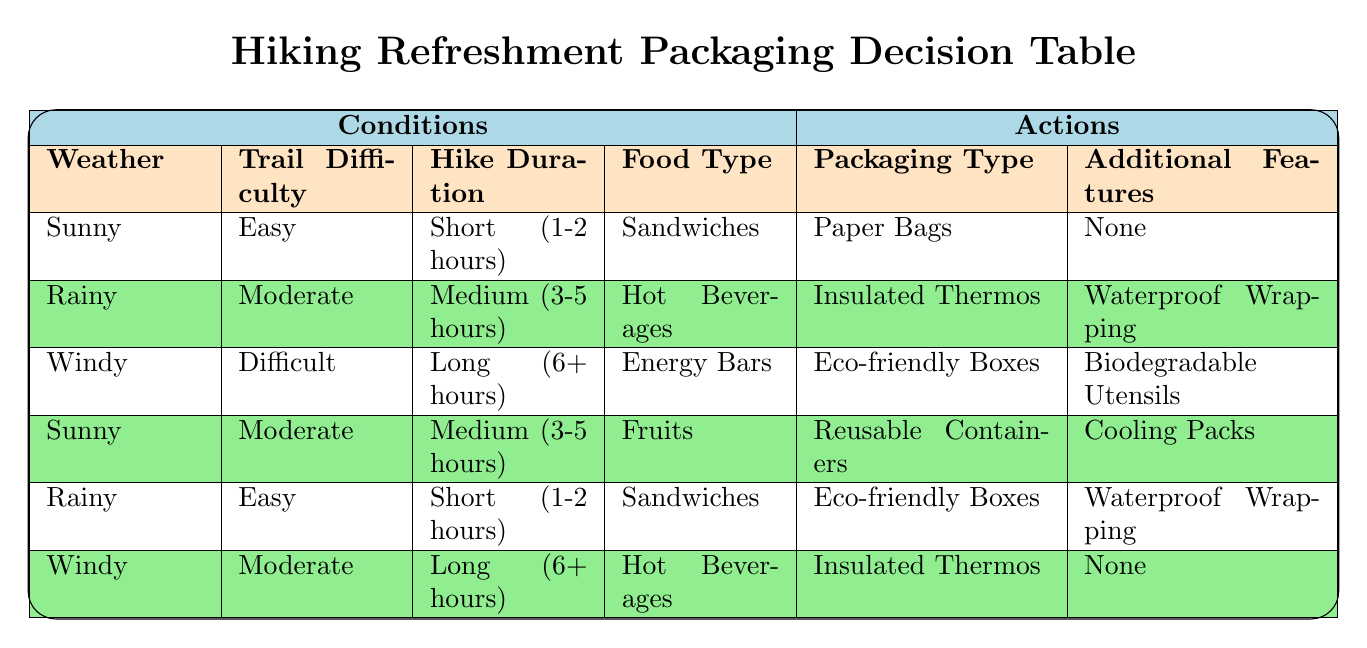What type of packaging should I use for sandwiches on a sunny day with an easy trail? According to the table, if the conditions are sunny, the trail is easy, the hike duration is short (1-2 hours), and the food type is sandwiches, the recommended packaging type is paper bags with no additional features. This is found in the first row of the table.
Answer: Paper bags If it's windy and the trail is difficult, what type of packaging should I avoid? The table indicates that when the conditions are windy and the trail is difficult, the suggested packaging type is eco-friendly boxes with biodegradable utensils. Thus, if looking for packaging to avoid, one could eliminate other options like insulated thermos or paper bags.
Answer: Avoid insulated thermos and paper bags Is waterproof wrapping required for hot beverages on a rainy day with moderate trail difficulty? The table specifies that for rainy weather, moderate trail difficulty, and hot beverages, the required packaging is insulated thermos with waterproof wrapping. Therefore, waterproof wrapping is indeed necessary in this scenario.
Answer: Yes What are the packaging options for fruits on a sunny day during a medium-duration hike? When checking the table for sunny weather, moderate trail difficulty, and medium hike duration with fruits, the only packaging option listed is reusable containers along with cooling packs. Hence, the available packaging options are reusable containers with cooling packs.
Answer: Reusable containers How many packaging types are suggested for a windy hike with hot beverages spanning a long duration? The table shows that for windy conditions and long hike duration with hot beverages, the packaging type is insulated thermos with additional features as none. Only one packaging type is considered here, therefore the total is one.
Answer: One If a group uses eco-friendly boxes for food during a short hike in rainy weather, what additional feature will they need? The table specifies that for rainy conditions, easy trail difficulty, short duration, and sandwiches, the packaging type is eco-friendly boxes which require waterproof wrapping as an additional feature. This means for rainy weather and eco-friendly boxes, waterproof wrapping is needed.
Answer: Waterproof wrapping What is the recommended additional feature when using reusable containers for fruits on a sunny day? According to the table, for sunny weather with moderate trail difficulty, medium hike duration, and fruits, the recommended packaging type is reusable containers, which requires cooling packs as the additional feature. Thus, cooling packs are advised in this scenario.
Answer: Cooling packs When is insulated thermos used without any additional features according to the table? The table indicates that insulated thermos is suggested without any additional features when the weather is windy and the trail difficulty is moderate with a long hike duration and hot beverages. Therefore, this specific combination leads to insulated thermos being used without extra features.
Answer: Windy, moderate trail, long duration, hot beverages 